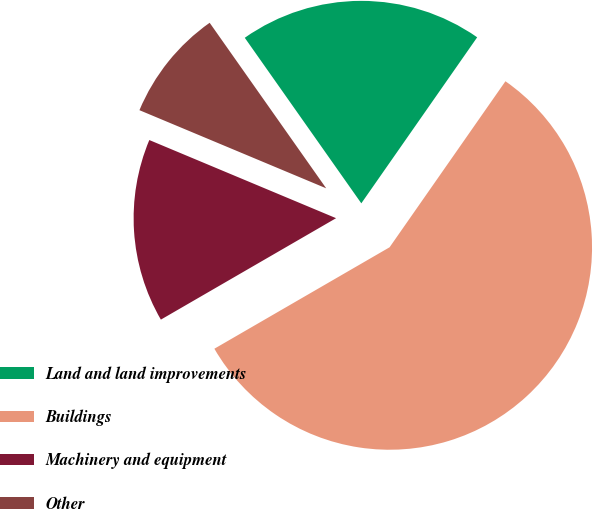<chart> <loc_0><loc_0><loc_500><loc_500><pie_chart><fcel>Land and land improvements<fcel>Buildings<fcel>Machinery and equipment<fcel>Other<nl><fcel>19.46%<fcel>56.95%<fcel>14.66%<fcel>8.93%<nl></chart> 